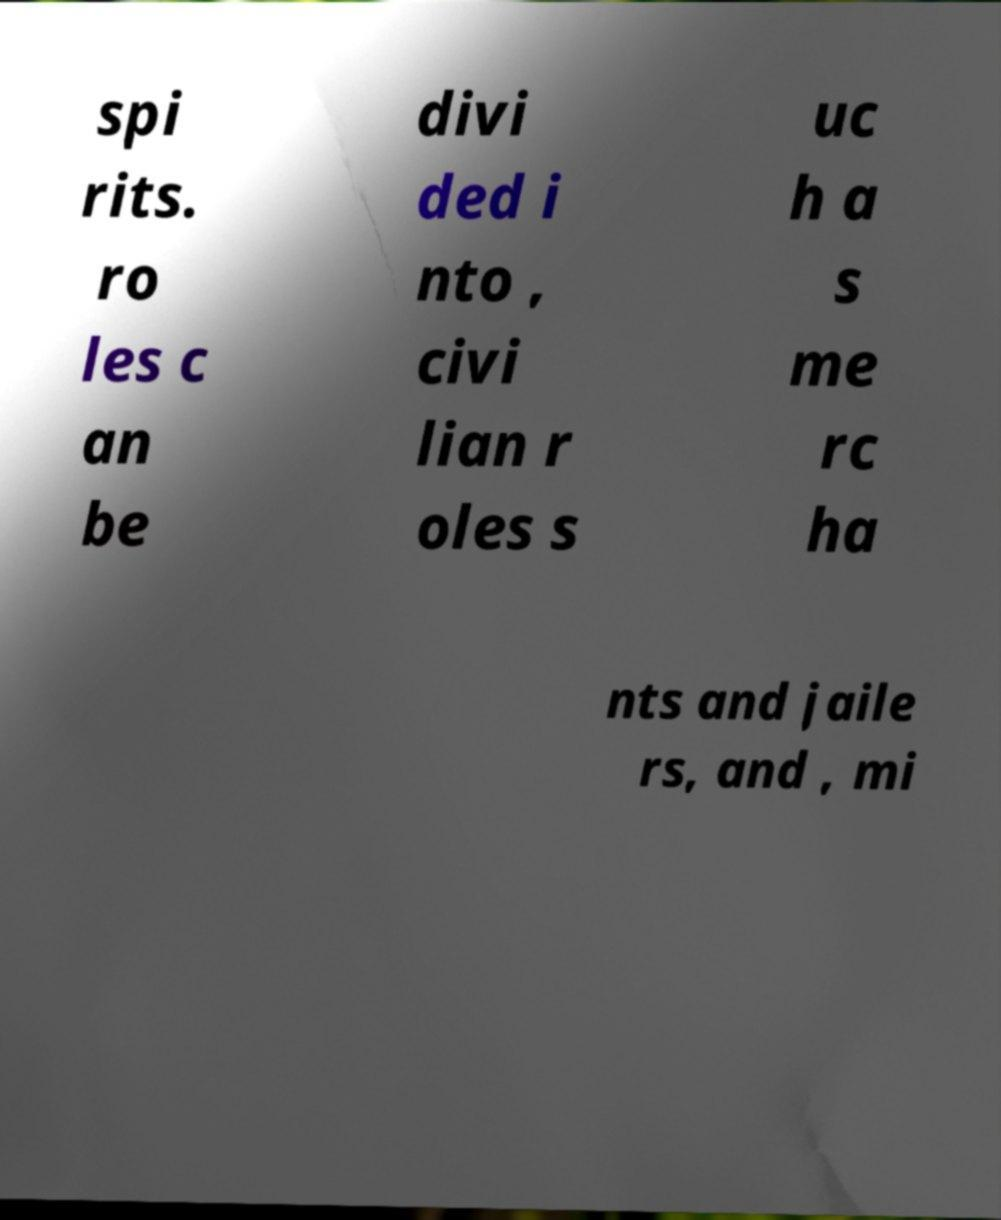What messages or text are displayed in this image? I need them in a readable, typed format. spi rits. ro les c an be divi ded i nto , civi lian r oles s uc h a s me rc ha nts and jaile rs, and , mi 